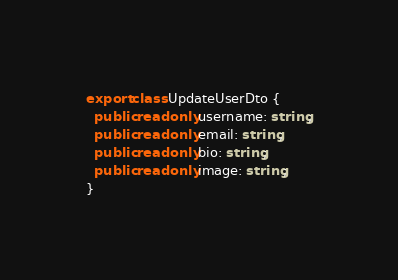Convert code to text. <code><loc_0><loc_0><loc_500><loc_500><_TypeScript_>export class UpdateUserDto {
  public readonly username: string;
  public readonly email: string;
  public readonly bio: string;
  public readonly image: string;
}
</code> 